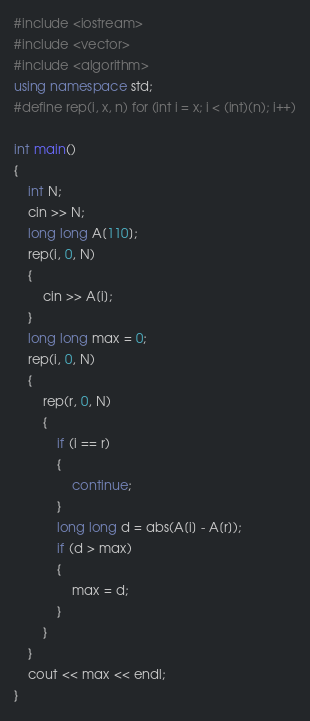<code> <loc_0><loc_0><loc_500><loc_500><_C++_>#include <iostream>
#include <vector>
#include <algorithm>
using namespace std;
#define rep(i, x, n) for (int i = x; i < (int)(n); i++)

int main()
{
    int N;
    cin >> N;
    long long A[110];
    rep(i, 0, N)
    {
        cin >> A[i];
    }
    long long max = 0;
    rep(i, 0, N)
    {
        rep(r, 0, N)
        {
            if (i == r)
            {
                continue;
            }
            long long d = abs(A[i] - A[r]);
            if (d > max)
            {
                max = d;
            }
        }
    }
    cout << max << endl;
}</code> 